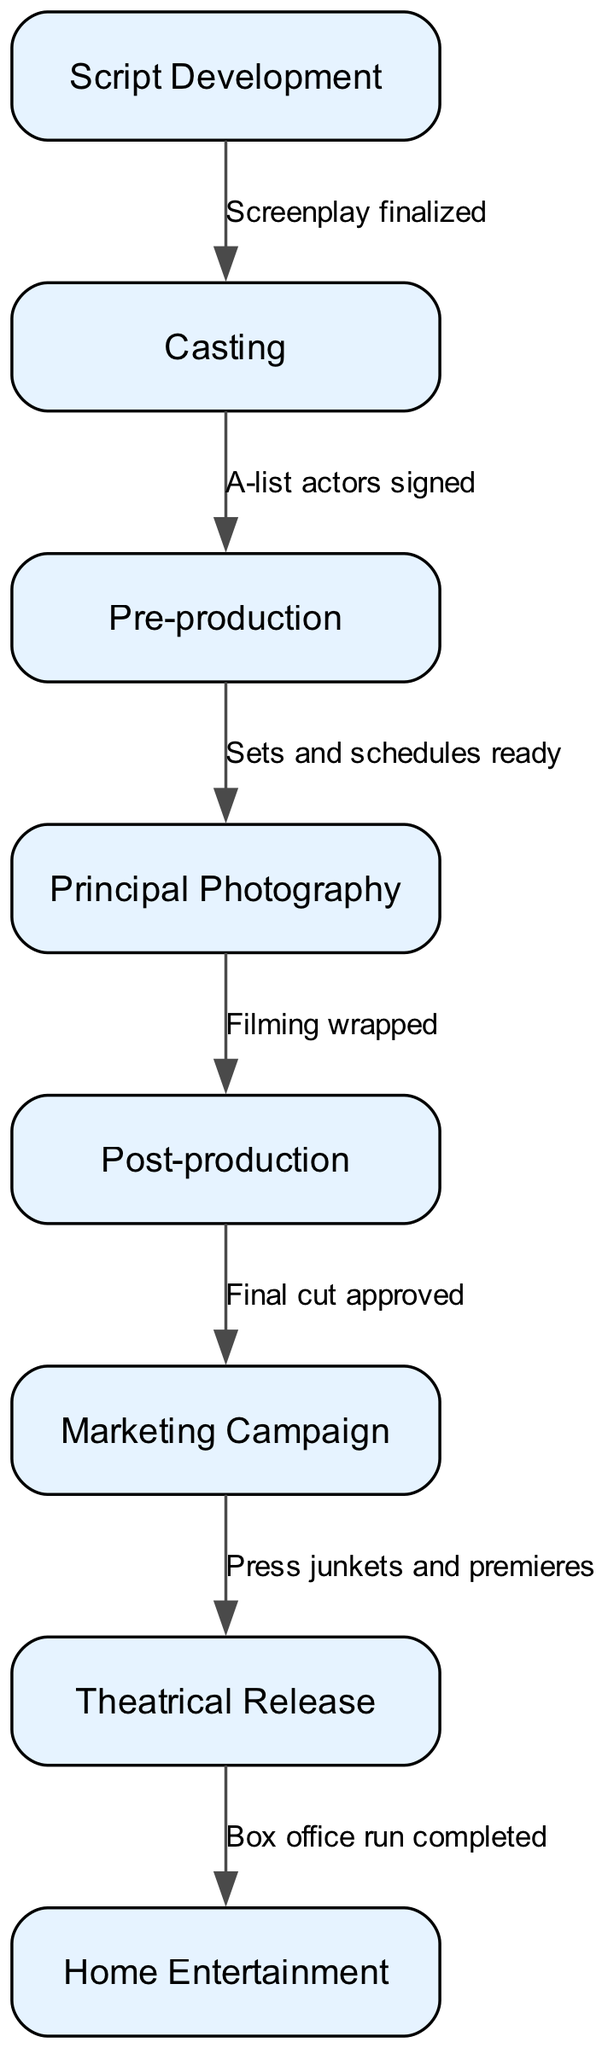What is the first step in film production according to the diagram? The diagram lists "Script Development" as the first node before any other process occurs.
Answer: Script Development How many nodes are there in the diagram? Counting the nodes in the diagram yields a total of eight distinct stages of film production.
Answer: 8 What is the relationship between "Casting" and "Pre-production"? The connection is indicated by an edge stating "A-list actors signed," which signifies that casting needs to be completed before pre-production starts.
Answer: A-list actors signed What stage follows "Post-production" in the film process? After "Post-production," the next stage in the diagram is "Marketing Campaign," as indicated by a direct connection from one node to the next.
Answer: Marketing Campaign How many edges connect the steps in the production process? By counting, it can be confirmed that there are seven edges that represent the relationships between the nodes in the diagram.
Answer: 7 What indicates the completion of "Principal Photography"? The edge labeled "Filming wrapped" signifies that this is the concluding event of the "Principal Photography" phase in the production process.
Answer: Filming wrapped What follows after the "Theatrical Release" phase? The process continues with "Home Entertainment," as noted in the diagram where the flow progresses from the theatrical release to home viewing.
Answer: Home Entertainment What must occur before "Sets and schedules ready"? The edge indicates that "Casting" must be completed before one can proceed to "Pre-production" where the sets and schedules are prepared.
Answer: A-list actors signed What is the final step in the flowchart? The diagram concludes with "Home Entertainment," marking the last phase in the film's distribution process.
Answer: Home Entertainment 